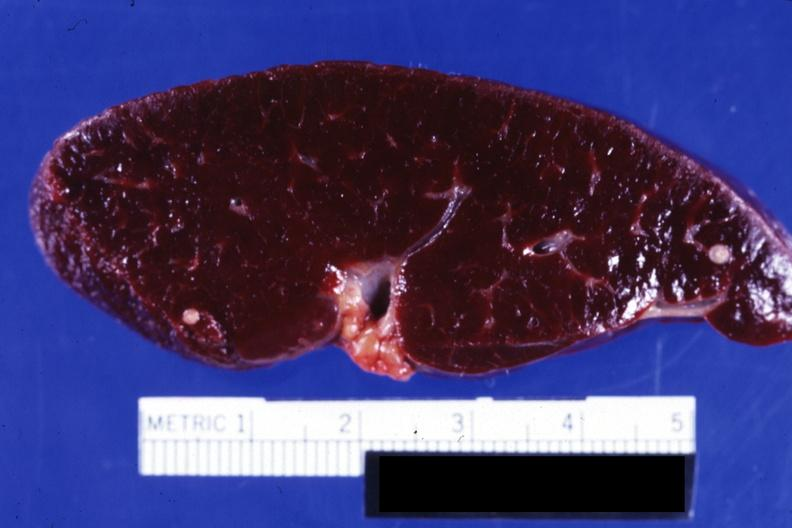s infarct present?
Answer the question using a single word or phrase. No 